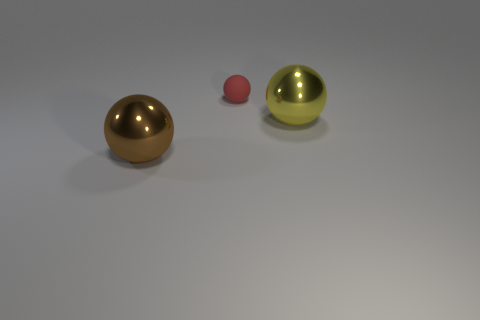Add 3 brown metal objects. How many objects exist? 6 Subtract 0 green cylinders. How many objects are left? 3 Subtract all brown balls. Subtract all large brown spheres. How many objects are left? 1 Add 3 shiny things. How many shiny things are left? 5 Add 3 tiny blocks. How many tiny blocks exist? 3 